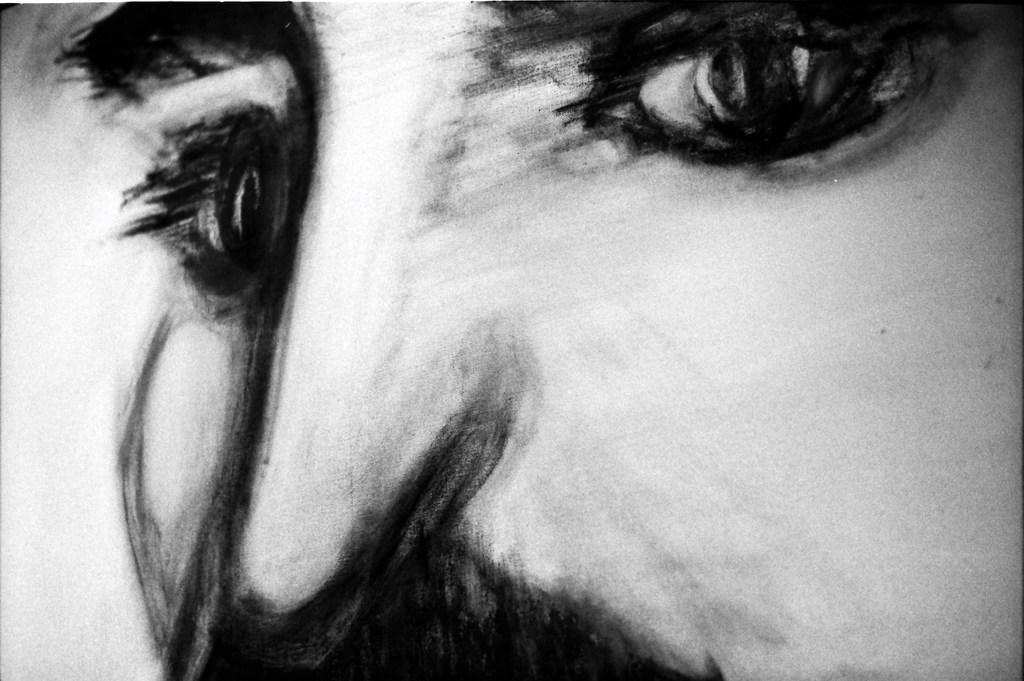Please provide a concise description of this image. In this picture we can see drawing of a person face. 